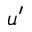Convert formula to latex. <formula><loc_0><loc_0><loc_500><loc_500>u ^ { \prime }</formula> 